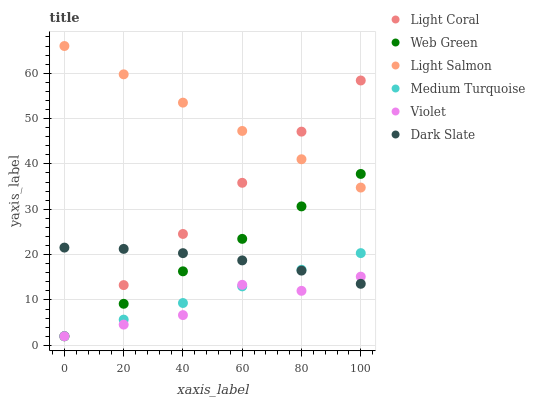Does Violet have the minimum area under the curve?
Answer yes or no. Yes. Does Light Salmon have the maximum area under the curve?
Answer yes or no. Yes. Does Web Green have the minimum area under the curve?
Answer yes or no. No. Does Web Green have the maximum area under the curve?
Answer yes or no. No. Is Web Green the smoothest?
Answer yes or no. Yes. Is Violet the roughest?
Answer yes or no. Yes. Is Light Coral the smoothest?
Answer yes or no. No. Is Light Coral the roughest?
Answer yes or no. No. Does Web Green have the lowest value?
Answer yes or no. Yes. Does Dark Slate have the lowest value?
Answer yes or no. No. Does Light Salmon have the highest value?
Answer yes or no. Yes. Does Web Green have the highest value?
Answer yes or no. No. Is Violet less than Light Salmon?
Answer yes or no. Yes. Is Light Salmon greater than Dark Slate?
Answer yes or no. Yes. Does Web Green intersect Light Coral?
Answer yes or no. Yes. Is Web Green less than Light Coral?
Answer yes or no. No. Is Web Green greater than Light Coral?
Answer yes or no. No. Does Violet intersect Light Salmon?
Answer yes or no. No. 